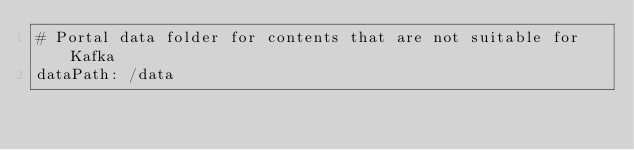Convert code to text. <code><loc_0><loc_0><loc_500><loc_500><_YAML_># Portal data folder for contents that are not suitable for Kafka
dataPath: /data
</code> 